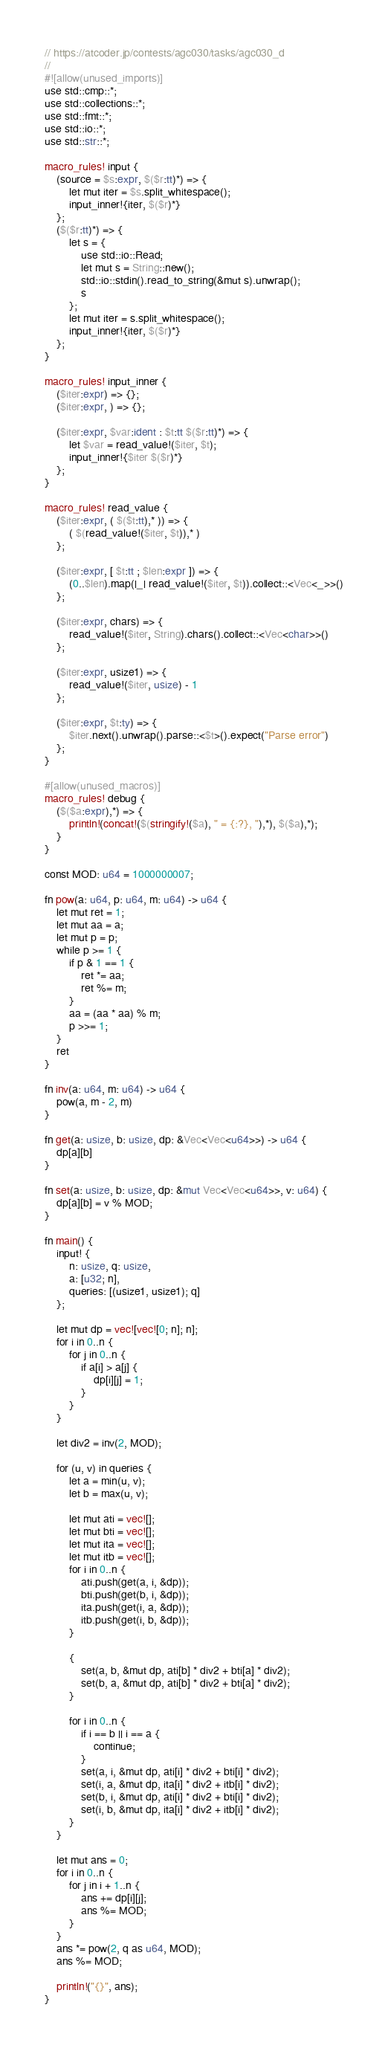Convert code to text. <code><loc_0><loc_0><loc_500><loc_500><_Rust_>// https://atcoder.jp/contests/agc030/tasks/agc030_d
//
#![allow(unused_imports)]
use std::cmp::*;
use std::collections::*;
use std::fmt::*;
use std::io::*;
use std::str::*;

macro_rules! input {
    (source = $s:expr, $($r:tt)*) => {
        let mut iter = $s.split_whitespace();
        input_inner!{iter, $($r)*}
    };
    ($($r:tt)*) => {
        let s = {
            use std::io::Read;
            let mut s = String::new();
            std::io::stdin().read_to_string(&mut s).unwrap();
            s
        };
        let mut iter = s.split_whitespace();
        input_inner!{iter, $($r)*}
    };
}

macro_rules! input_inner {
    ($iter:expr) => {};
    ($iter:expr, ) => {};

    ($iter:expr, $var:ident : $t:tt $($r:tt)*) => {
        let $var = read_value!($iter, $t);
        input_inner!{$iter $($r)*}
    };
}

macro_rules! read_value {
    ($iter:expr, ( $($t:tt),* )) => {
        ( $(read_value!($iter, $t)),* )
    };

    ($iter:expr, [ $t:tt ; $len:expr ]) => {
        (0..$len).map(|_| read_value!($iter, $t)).collect::<Vec<_>>()
    };

    ($iter:expr, chars) => {
        read_value!($iter, String).chars().collect::<Vec<char>>()
    };

    ($iter:expr, usize1) => {
        read_value!($iter, usize) - 1
    };

    ($iter:expr, $t:ty) => {
        $iter.next().unwrap().parse::<$t>().expect("Parse error")
    };
}

#[allow(unused_macros)]
macro_rules! debug {
    ($($a:expr),*) => {
        println!(concat!($(stringify!($a), " = {:?}, "),*), $($a),*);
    }
}

const MOD: u64 = 1000000007;

fn pow(a: u64, p: u64, m: u64) -> u64 {
    let mut ret = 1;
    let mut aa = a;
    let mut p = p;
    while p >= 1 {
        if p & 1 == 1 {
            ret *= aa;
            ret %= m;
        }
        aa = (aa * aa) % m;
        p >>= 1;
    }
    ret
}

fn inv(a: u64, m: u64) -> u64 {
    pow(a, m - 2, m)
}

fn get(a: usize, b: usize, dp: &Vec<Vec<u64>>) -> u64 {
    dp[a][b]
}

fn set(a: usize, b: usize, dp: &mut Vec<Vec<u64>>, v: u64) {
    dp[a][b] = v % MOD;
}

fn main() {
    input! {
        n: usize, q: usize,
        a: [u32; n],
        queries: [(usize1, usize1); q]
    };

    let mut dp = vec![vec![0; n]; n];
    for i in 0..n {
        for j in 0..n {
            if a[i] > a[j] {
                dp[i][j] = 1;
            }
        }
    }

    let div2 = inv(2, MOD);

    for (u, v) in queries {
        let a = min(u, v);
        let b = max(u, v);

        let mut ati = vec![];
        let mut bti = vec![];
        let mut ita = vec![];
        let mut itb = vec![];
        for i in 0..n {
            ati.push(get(a, i, &dp));
            bti.push(get(b, i, &dp));
            ita.push(get(i, a, &dp));
            itb.push(get(i, b, &dp));
        }

        {
            set(a, b, &mut dp, ati[b] * div2 + bti[a] * div2);
            set(b, a, &mut dp, ati[b] * div2 + bti[a] * div2);
        }

        for i in 0..n {
            if i == b || i == a {
                continue;
            }
            set(a, i, &mut dp, ati[i] * div2 + bti[i] * div2);
            set(i, a, &mut dp, ita[i] * div2 + itb[i] * div2);
            set(b, i, &mut dp, ati[i] * div2 + bti[i] * div2);
            set(i, b, &mut dp, ita[i] * div2 + itb[i] * div2);
        }
    }

    let mut ans = 0;
    for i in 0..n {
        for j in i + 1..n {
            ans += dp[i][j];
            ans %= MOD;
        }
    }
    ans *= pow(2, q as u64, MOD);
    ans %= MOD;

    println!("{}", ans);
}
</code> 